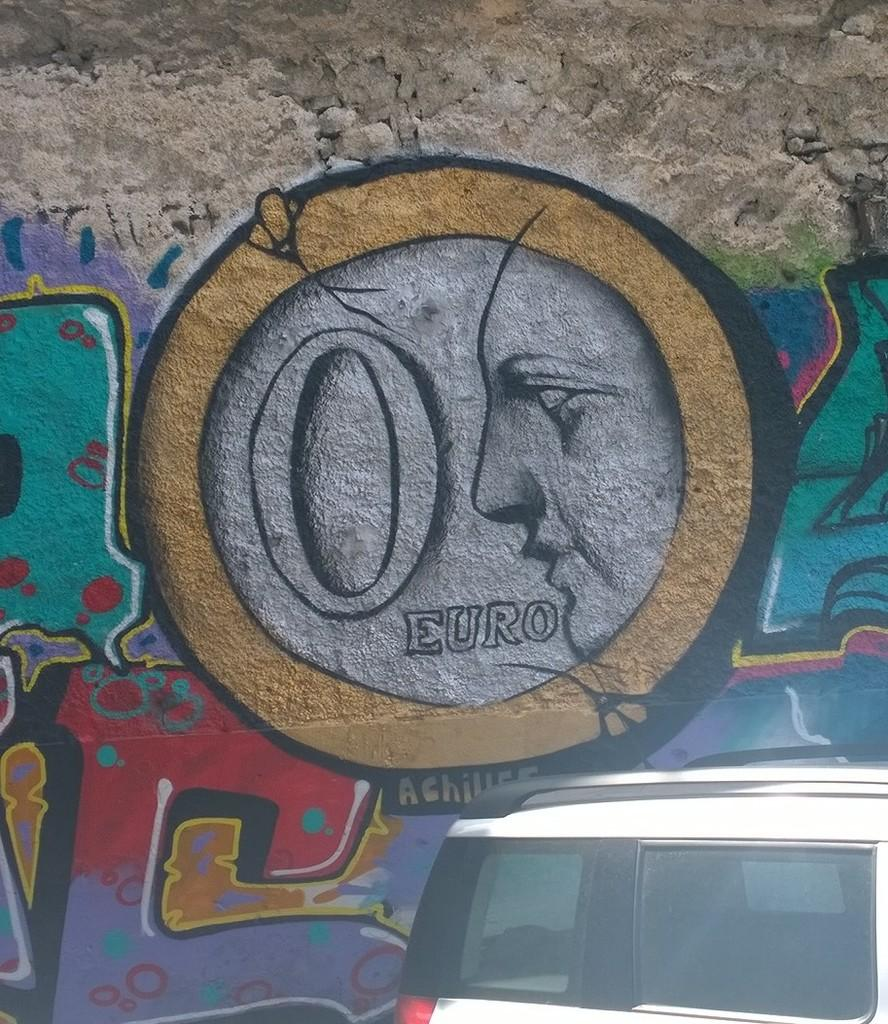What is depicted on the wall in the image? There is a wall painting in the image. What can be said about the colors used in the wall painting? The wall painting has different colors. What else can be seen in the image besides the wall painting? There is a vehicle in the image. What colors are used for the vehicle in the image? The vehicle is white and black in color. What type of voyage is depicted in the wall painting? There is no voyage depicted in the wall painting; it is a stationary image on the wall. 